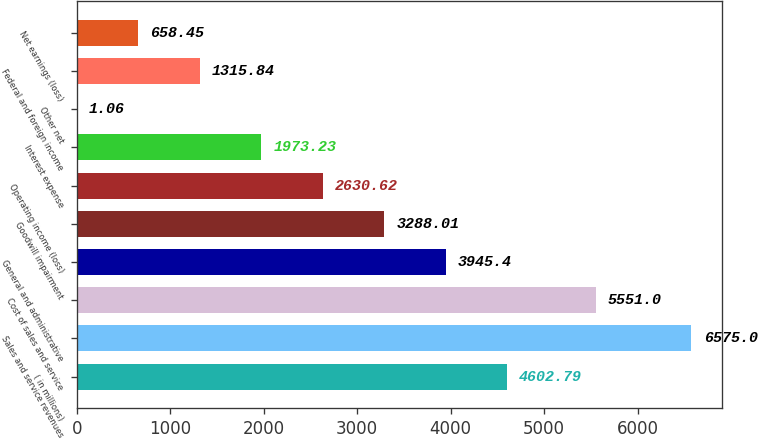Convert chart to OTSL. <chart><loc_0><loc_0><loc_500><loc_500><bar_chart><fcel>( in millions)<fcel>Sales and service revenues<fcel>Cost of sales and service<fcel>General and administrative<fcel>Goodwill impairment<fcel>Operating income (loss)<fcel>Interest expense<fcel>Other net<fcel>Federal and foreign income<fcel>Net earnings (loss)<nl><fcel>4602.79<fcel>6575<fcel>5551<fcel>3945.4<fcel>3288.01<fcel>2630.62<fcel>1973.23<fcel>1.06<fcel>1315.84<fcel>658.45<nl></chart> 